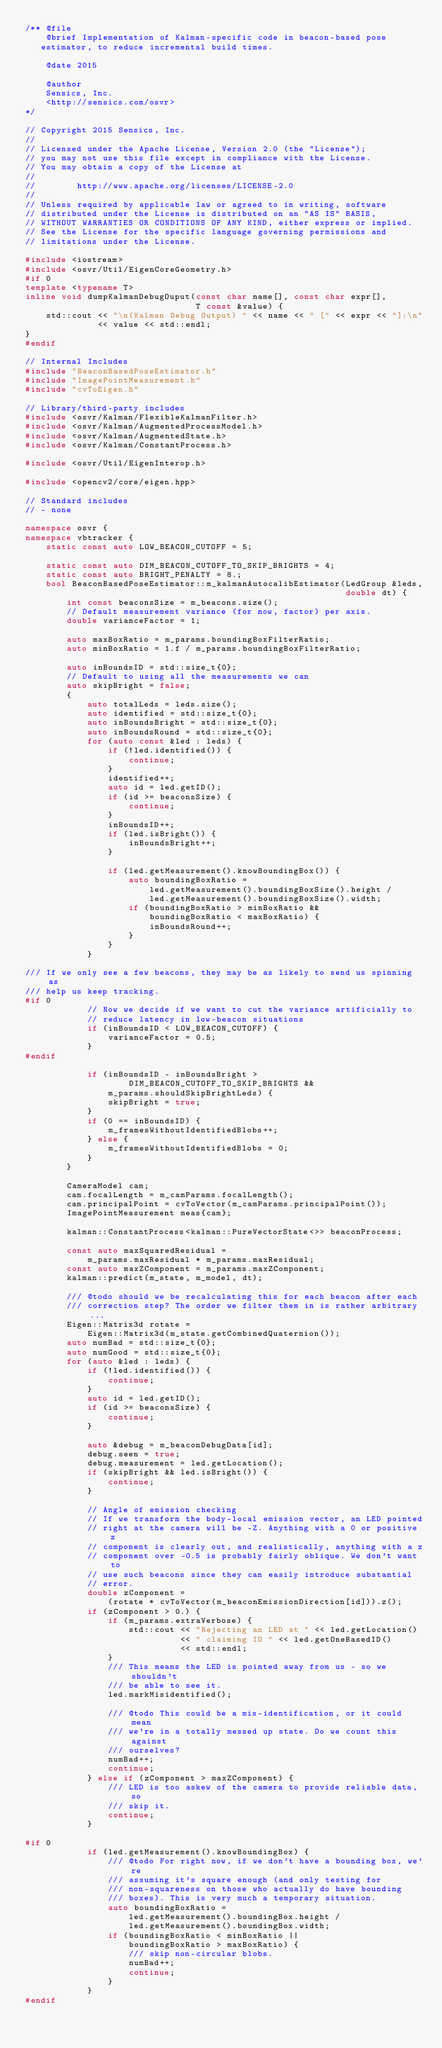<code> <loc_0><loc_0><loc_500><loc_500><_C++_>/** @file
    @brief Implementation of Kalman-specific code in beacon-based pose
   estimator, to reduce incremental build times.

    @date 2015

    @author
    Sensics, Inc.
    <http://sensics.com/osvr>
*/

// Copyright 2015 Sensics, Inc.
//
// Licensed under the Apache License, Version 2.0 (the "License");
// you may not use this file except in compliance with the License.
// You may obtain a copy of the License at
//
//        http://www.apache.org/licenses/LICENSE-2.0
//
// Unless required by applicable law or agreed to in writing, software
// distributed under the License is distributed on an "AS IS" BASIS,
// WITHOUT WARRANTIES OR CONDITIONS OF ANY KIND, either express or implied.
// See the License for the specific language governing permissions and
// limitations under the License.

#include <iostream>
#include <osvr/Util/EigenCoreGeometry.h>
#if 0
template <typename T>
inline void dumpKalmanDebugOuput(const char name[], const char expr[],
                                 T const &value) {
    std::cout << "\n(Kalman Debug Output) " << name << " [" << expr << "]:\n"
              << value << std::endl;
}
#endif

// Internal Includes
#include "BeaconBasedPoseEstimator.h"
#include "ImagePointMeasurement.h"
#include "cvToEigen.h"

// Library/third-party includes
#include <osvr/Kalman/FlexibleKalmanFilter.h>
#include <osvr/Kalman/AugmentedProcessModel.h>
#include <osvr/Kalman/AugmentedState.h>
#include <osvr/Kalman/ConstantProcess.h>

#include <osvr/Util/EigenInterop.h>

#include <opencv2/core/eigen.hpp>

// Standard includes
// - none

namespace osvr {
namespace vbtracker {
    static const auto LOW_BEACON_CUTOFF = 5;

    static const auto DIM_BEACON_CUTOFF_TO_SKIP_BRIGHTS = 4;
    static const auto BRIGHT_PENALTY = 8.;
    bool BeaconBasedPoseEstimator::m_kalmanAutocalibEstimator(LedGroup &leds,
                                                              double dt) {
        int const beaconsSize = m_beacons.size();
        // Default measurement variance (for now, factor) per axis.
        double varianceFactor = 1;

        auto maxBoxRatio = m_params.boundingBoxFilterRatio;
        auto minBoxRatio = 1.f / m_params.boundingBoxFilterRatio;

        auto inBoundsID = std::size_t{0};
        // Default to using all the measurements we can
        auto skipBright = false;
        {
            auto totalLeds = leds.size();
            auto identified = std::size_t{0};
            auto inBoundsBright = std::size_t{0};
            auto inBoundsRound = std::size_t{0};
            for (auto const &led : leds) {
                if (!led.identified()) {
                    continue;
                }
                identified++;
                auto id = led.getID();
                if (id >= beaconsSize) {
                    continue;
                }
                inBoundsID++;
                if (led.isBright()) {
                    inBoundsBright++;
                }

                if (led.getMeasurement().knowBoundingBox()) {
                    auto boundingBoxRatio =
                        led.getMeasurement().boundingBoxSize().height /
                        led.getMeasurement().boundingBoxSize().width;
                    if (boundingBoxRatio > minBoxRatio &&
                        boundingBoxRatio < maxBoxRatio) {
                        inBoundsRound++;
                    }
                }
            }

/// If we only see a few beacons, they may be as likely to send us spinning as
/// help us keep tracking.
#if 0
            // Now we decide if we want to cut the variance artificially to
            // reduce latency in low-beacon situations
            if (inBoundsID < LOW_BEACON_CUTOFF) {
                varianceFactor = 0.5;
            }
#endif

            if (inBoundsID - inBoundsBright >
                    DIM_BEACON_CUTOFF_TO_SKIP_BRIGHTS &&
                m_params.shouldSkipBrightLeds) {
                skipBright = true;
            }
            if (0 == inBoundsID) {
                m_framesWithoutIdentifiedBlobs++;
            } else {
                m_framesWithoutIdentifiedBlobs = 0;
            }
        }

        CameraModel cam;
        cam.focalLength = m_camParams.focalLength();
        cam.principalPoint = cvToVector(m_camParams.principalPoint());
        ImagePointMeasurement meas{cam};

        kalman::ConstantProcess<kalman::PureVectorState<>> beaconProcess;

        const auto maxSquaredResidual =
            m_params.maxResidual * m_params.maxResidual;
        const auto maxZComponent = m_params.maxZComponent;
        kalman::predict(m_state, m_model, dt);

        /// @todo should we be recalculating this for each beacon after each
        /// correction step? The order we filter them in is rather arbitrary...
        Eigen::Matrix3d rotate =
            Eigen::Matrix3d(m_state.getCombinedQuaternion());
        auto numBad = std::size_t{0};
        auto numGood = std::size_t{0};
        for (auto &led : leds) {
            if (!led.identified()) {
                continue;
            }
            auto id = led.getID();
            if (id >= beaconsSize) {
                continue;
            }

            auto &debug = m_beaconDebugData[id];
            debug.seen = true;
            debug.measurement = led.getLocation();
            if (skipBright && led.isBright()) {
                continue;
            }

            // Angle of emission checking
            // If we transform the body-local emission vector, an LED pointed
            // right at the camera will be -Z. Anything with a 0 or positive z
            // component is clearly out, and realistically, anything with a z
            // component over -0.5 is probably fairly oblique. We don't want to
            // use such beacons since they can easily introduce substantial
            // error.
            double zComponent =
                (rotate * cvToVector(m_beaconEmissionDirection[id])).z();
            if (zComponent > 0.) {
                if (m_params.extraVerbose) {
                    std::cout << "Rejecting an LED at " << led.getLocation()
                              << " claiming ID " << led.getOneBasedID()
                              << std::endl;
                }
                /// This means the LED is pointed away from us - so we shouldn't
                /// be able to see it.
                led.markMisidentified();

                /// @todo This could be a mis-identification, or it could mean
                /// we're in a totally messed up state. Do we count this against
                /// ourselves?
                numBad++;
                continue;
            } else if (zComponent > maxZComponent) {
                /// LED is too askew of the camera to provide reliable data, so
                /// skip it.
                continue;
            }

#if 0
            if (led.getMeasurement().knowBoundingBox) {
                /// @todo For right now, if we don't have a bounding box, we're
                /// assuming it's square enough (and only testing for
                /// non-squareness on those who actually do have bounding
                /// boxes). This is very much a temporary situation.
                auto boundingBoxRatio =
                    led.getMeasurement().boundingBox.height /
                    led.getMeasurement().boundingBox.width;
                if (boundingBoxRatio < minBoxRatio ||
                    boundingBoxRatio > maxBoxRatio) {
                    /// skip non-circular blobs.
                    numBad++;
                    continue;
                }
            }
#endif
</code> 